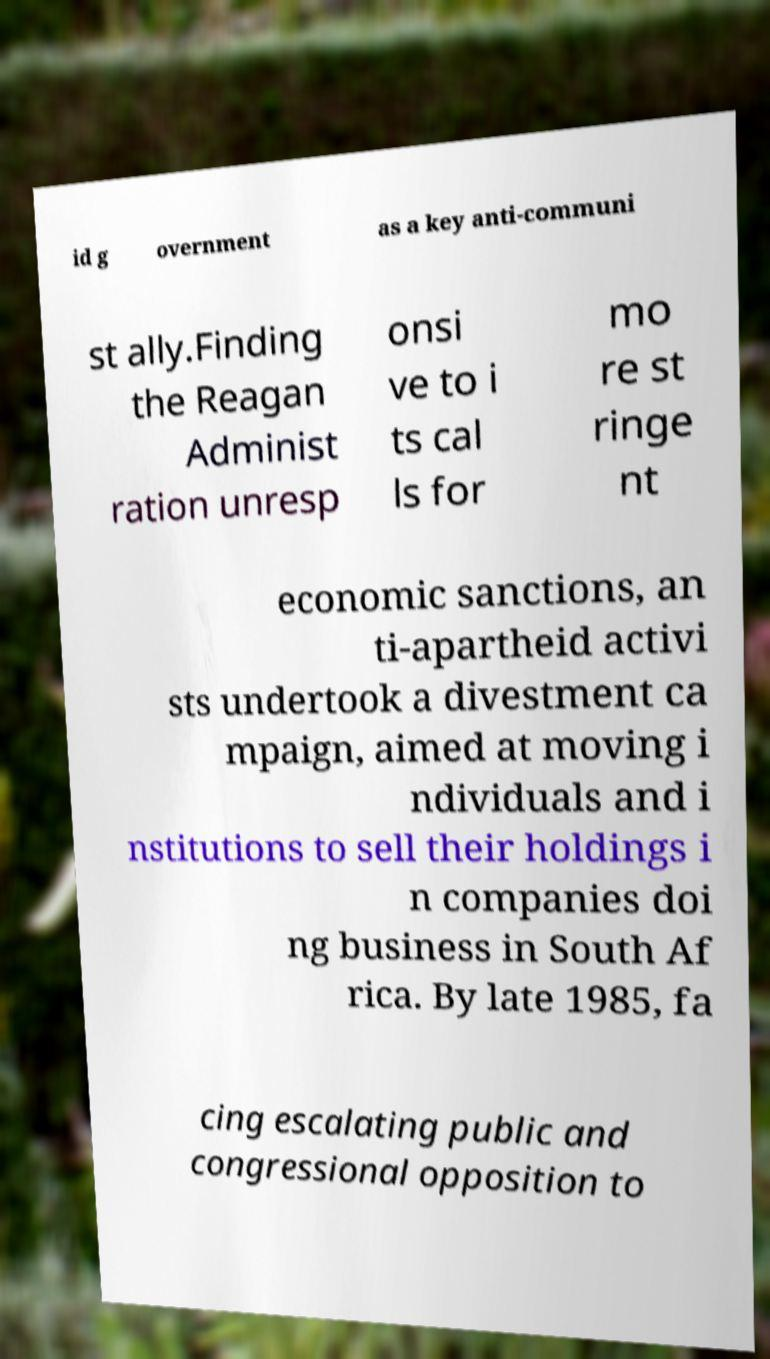I need the written content from this picture converted into text. Can you do that? id g overnment as a key anti-communi st ally.Finding the Reagan Administ ration unresp onsi ve to i ts cal ls for mo re st ringe nt economic sanctions, an ti-apartheid activi sts undertook a divestment ca mpaign, aimed at moving i ndividuals and i nstitutions to sell their holdings i n companies doi ng business in South Af rica. By late 1985, fa cing escalating public and congressional opposition to 